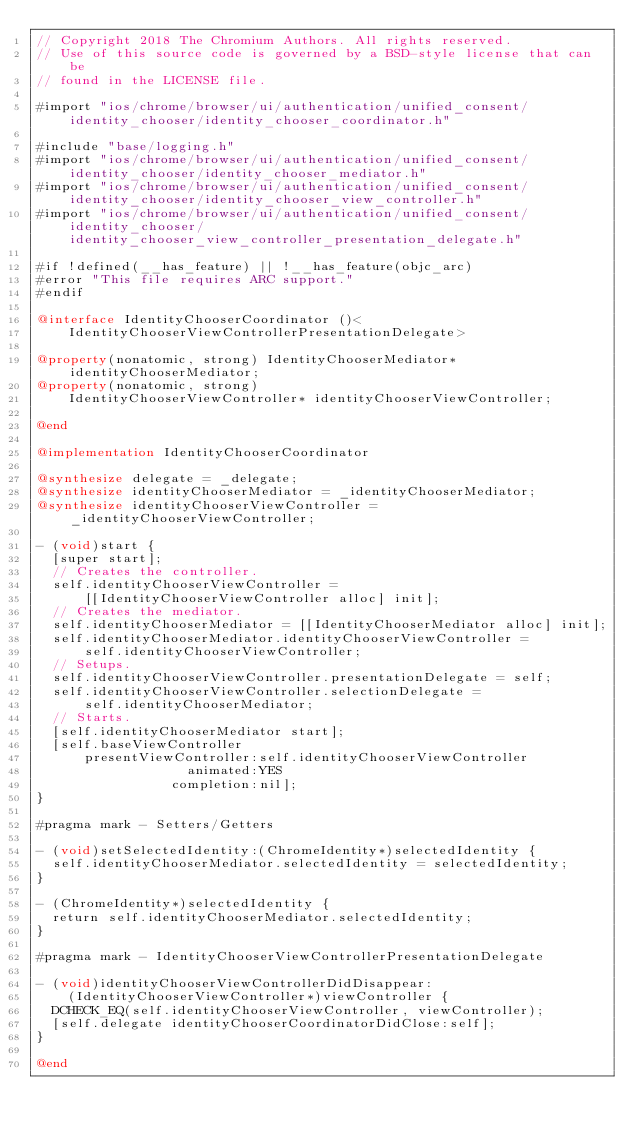<code> <loc_0><loc_0><loc_500><loc_500><_ObjectiveC_>// Copyright 2018 The Chromium Authors. All rights reserved.
// Use of this source code is governed by a BSD-style license that can be
// found in the LICENSE file.

#import "ios/chrome/browser/ui/authentication/unified_consent/identity_chooser/identity_chooser_coordinator.h"

#include "base/logging.h"
#import "ios/chrome/browser/ui/authentication/unified_consent/identity_chooser/identity_chooser_mediator.h"
#import "ios/chrome/browser/ui/authentication/unified_consent/identity_chooser/identity_chooser_view_controller.h"
#import "ios/chrome/browser/ui/authentication/unified_consent/identity_chooser/identity_chooser_view_controller_presentation_delegate.h"

#if !defined(__has_feature) || !__has_feature(objc_arc)
#error "This file requires ARC support."
#endif

@interface IdentityChooserCoordinator ()<
    IdentityChooserViewControllerPresentationDelegate>

@property(nonatomic, strong) IdentityChooserMediator* identityChooserMediator;
@property(nonatomic, strong)
    IdentityChooserViewController* identityChooserViewController;

@end

@implementation IdentityChooserCoordinator

@synthesize delegate = _delegate;
@synthesize identityChooserMediator = _identityChooserMediator;
@synthesize identityChooserViewController = _identityChooserViewController;

- (void)start {
  [super start];
  // Creates the controller.
  self.identityChooserViewController =
      [[IdentityChooserViewController alloc] init];
  // Creates the mediator.
  self.identityChooserMediator = [[IdentityChooserMediator alloc] init];
  self.identityChooserMediator.identityChooserViewController =
      self.identityChooserViewController;
  // Setups.
  self.identityChooserViewController.presentationDelegate = self;
  self.identityChooserViewController.selectionDelegate =
      self.identityChooserMediator;
  // Starts.
  [self.identityChooserMediator start];
  [self.baseViewController
      presentViewController:self.identityChooserViewController
                   animated:YES
                 completion:nil];
}

#pragma mark - Setters/Getters

- (void)setSelectedIdentity:(ChromeIdentity*)selectedIdentity {
  self.identityChooserMediator.selectedIdentity = selectedIdentity;
}

- (ChromeIdentity*)selectedIdentity {
  return self.identityChooserMediator.selectedIdentity;
}

#pragma mark - IdentityChooserViewControllerPresentationDelegate

- (void)identityChooserViewControllerDidDisappear:
    (IdentityChooserViewController*)viewController {
  DCHECK_EQ(self.identityChooserViewController, viewController);
  [self.delegate identityChooserCoordinatorDidClose:self];
}

@end
</code> 